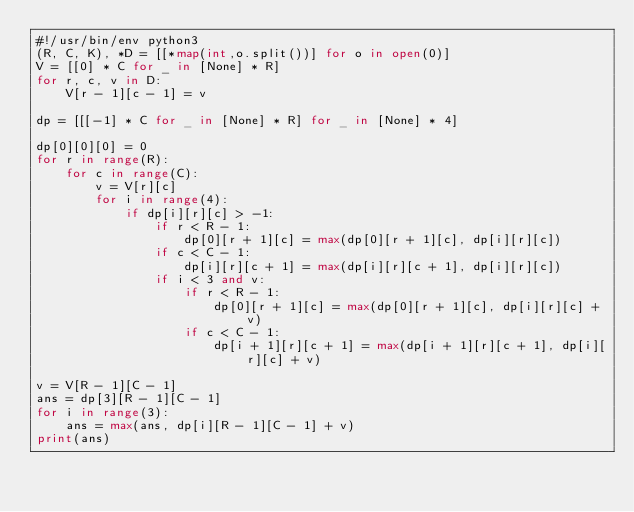Convert code to text. <code><loc_0><loc_0><loc_500><loc_500><_Python_>#!/usr/bin/env python3
(R, C, K), *D = [[*map(int,o.split())] for o in open(0)]
V = [[0] * C for _ in [None] * R]
for r, c, v in D:
    V[r - 1][c - 1] = v

dp = [[[-1] * C for _ in [None] * R] for _ in [None] * 4]

dp[0][0][0] = 0
for r in range(R):
    for c in range(C):
        v = V[r][c]
        for i in range(4):
            if dp[i][r][c] > -1:
                if r < R - 1:
                    dp[0][r + 1][c] = max(dp[0][r + 1][c], dp[i][r][c])
                if c < C - 1:
                    dp[i][r][c + 1] = max(dp[i][r][c + 1], dp[i][r][c])
                if i < 3 and v:
                    if r < R - 1:
                        dp[0][r + 1][c] = max(dp[0][r + 1][c], dp[i][r][c] + v)
                    if c < C - 1:
                        dp[i + 1][r][c + 1] = max(dp[i + 1][r][c + 1], dp[i][r][c] + v)

v = V[R - 1][C - 1]
ans = dp[3][R - 1][C - 1]
for i in range(3):
    ans = max(ans, dp[i][R - 1][C - 1] + v)
print(ans)</code> 